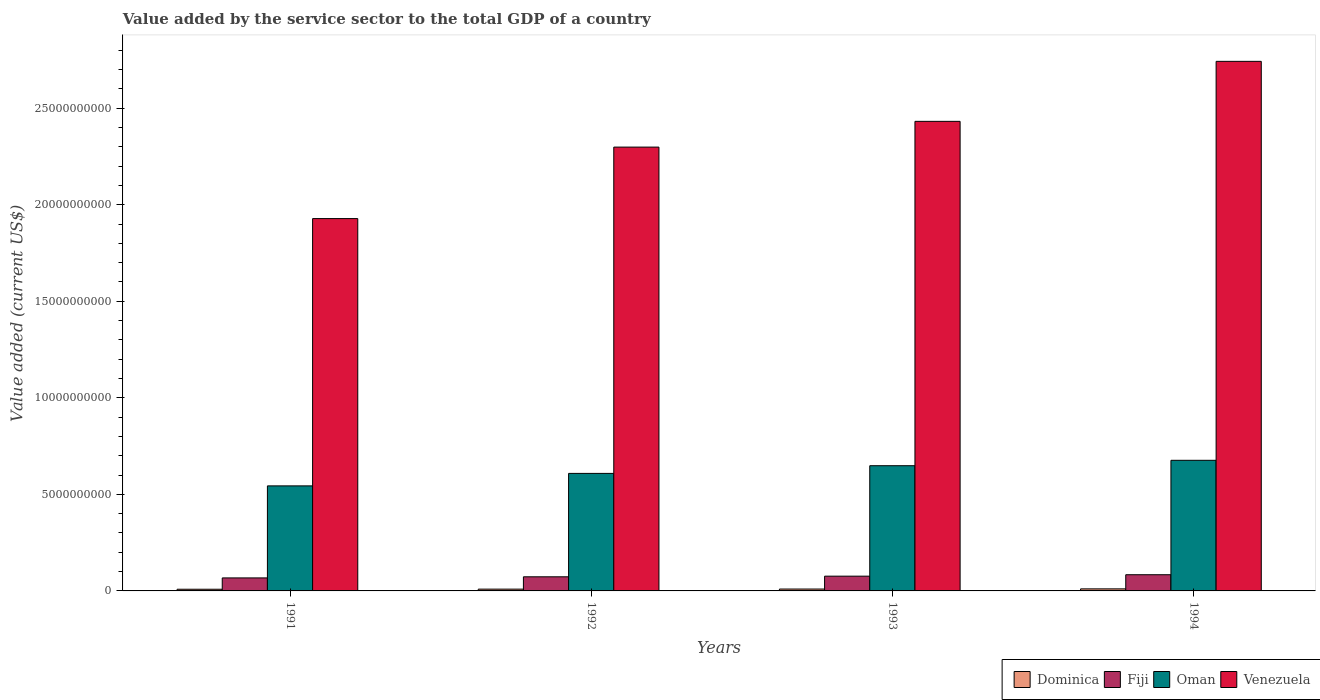How many groups of bars are there?
Your answer should be very brief. 4. In how many cases, is the number of bars for a given year not equal to the number of legend labels?
Ensure brevity in your answer.  0. What is the value added by the service sector to the total GDP in Oman in 1993?
Keep it short and to the point. 6.48e+09. Across all years, what is the maximum value added by the service sector to the total GDP in Oman?
Keep it short and to the point. 6.76e+09. Across all years, what is the minimum value added by the service sector to the total GDP in Dominica?
Keep it short and to the point. 8.67e+07. In which year was the value added by the service sector to the total GDP in Venezuela maximum?
Your answer should be compact. 1994. What is the total value added by the service sector to the total GDP in Venezuela in the graph?
Offer a terse response. 9.40e+1. What is the difference between the value added by the service sector to the total GDP in Fiji in 1991 and that in 1994?
Your answer should be very brief. -1.64e+08. What is the difference between the value added by the service sector to the total GDP in Dominica in 1992 and the value added by the service sector to the total GDP in Venezuela in 1993?
Keep it short and to the point. -2.42e+1. What is the average value added by the service sector to the total GDP in Oman per year?
Your answer should be compact. 6.19e+09. In the year 1993, what is the difference between the value added by the service sector to the total GDP in Fiji and value added by the service sector to the total GDP in Oman?
Provide a short and direct response. -5.72e+09. In how many years, is the value added by the service sector to the total GDP in Fiji greater than 18000000000 US$?
Offer a very short reply. 0. What is the ratio of the value added by the service sector to the total GDP in Fiji in 1991 to that in 1994?
Your answer should be very brief. 0.8. Is the value added by the service sector to the total GDP in Venezuela in 1991 less than that in 1993?
Make the answer very short. Yes. Is the difference between the value added by the service sector to the total GDP in Fiji in 1992 and 1994 greater than the difference between the value added by the service sector to the total GDP in Oman in 1992 and 1994?
Provide a short and direct response. Yes. What is the difference between the highest and the second highest value added by the service sector to the total GDP in Oman?
Your answer should be compact. 2.81e+08. What is the difference between the highest and the lowest value added by the service sector to the total GDP in Oman?
Give a very brief answer. 1.32e+09. Is the sum of the value added by the service sector to the total GDP in Venezuela in 1991 and 1994 greater than the maximum value added by the service sector to the total GDP in Fiji across all years?
Your answer should be very brief. Yes. What does the 1st bar from the left in 1991 represents?
Provide a short and direct response. Dominica. What does the 4th bar from the right in 1993 represents?
Ensure brevity in your answer.  Dominica. Is it the case that in every year, the sum of the value added by the service sector to the total GDP in Venezuela and value added by the service sector to the total GDP in Oman is greater than the value added by the service sector to the total GDP in Fiji?
Your answer should be compact. Yes. How many bars are there?
Your answer should be very brief. 16. How many years are there in the graph?
Keep it short and to the point. 4. What is the difference between two consecutive major ticks on the Y-axis?
Make the answer very short. 5.00e+09. Does the graph contain grids?
Keep it short and to the point. No. Where does the legend appear in the graph?
Your response must be concise. Bottom right. What is the title of the graph?
Keep it short and to the point. Value added by the service sector to the total GDP of a country. What is the label or title of the Y-axis?
Your response must be concise. Value added (current US$). What is the Value added (current US$) of Dominica in 1991?
Your answer should be compact. 8.67e+07. What is the Value added (current US$) in Fiji in 1991?
Your answer should be compact. 6.74e+08. What is the Value added (current US$) of Oman in 1991?
Your response must be concise. 5.44e+09. What is the Value added (current US$) of Venezuela in 1991?
Your response must be concise. 1.93e+1. What is the Value added (current US$) in Dominica in 1992?
Your answer should be very brief. 9.25e+07. What is the Value added (current US$) of Fiji in 1992?
Your response must be concise. 7.31e+08. What is the Value added (current US$) in Oman in 1992?
Your answer should be very brief. 6.09e+09. What is the Value added (current US$) in Venezuela in 1992?
Your answer should be compact. 2.30e+1. What is the Value added (current US$) in Dominica in 1993?
Give a very brief answer. 9.78e+07. What is the Value added (current US$) of Fiji in 1993?
Give a very brief answer. 7.64e+08. What is the Value added (current US$) in Oman in 1993?
Provide a short and direct response. 6.48e+09. What is the Value added (current US$) in Venezuela in 1993?
Make the answer very short. 2.43e+1. What is the Value added (current US$) in Dominica in 1994?
Your answer should be very brief. 1.06e+08. What is the Value added (current US$) of Fiji in 1994?
Your response must be concise. 8.38e+08. What is the Value added (current US$) in Oman in 1994?
Your response must be concise. 6.76e+09. What is the Value added (current US$) of Venezuela in 1994?
Give a very brief answer. 2.74e+1. Across all years, what is the maximum Value added (current US$) in Dominica?
Give a very brief answer. 1.06e+08. Across all years, what is the maximum Value added (current US$) in Fiji?
Offer a very short reply. 8.38e+08. Across all years, what is the maximum Value added (current US$) in Oman?
Your response must be concise. 6.76e+09. Across all years, what is the maximum Value added (current US$) in Venezuela?
Ensure brevity in your answer.  2.74e+1. Across all years, what is the minimum Value added (current US$) of Dominica?
Provide a succinct answer. 8.67e+07. Across all years, what is the minimum Value added (current US$) of Fiji?
Offer a terse response. 6.74e+08. Across all years, what is the minimum Value added (current US$) in Oman?
Provide a short and direct response. 5.44e+09. Across all years, what is the minimum Value added (current US$) of Venezuela?
Provide a short and direct response. 1.93e+1. What is the total Value added (current US$) of Dominica in the graph?
Your response must be concise. 3.83e+08. What is the total Value added (current US$) of Fiji in the graph?
Provide a succinct answer. 3.01e+09. What is the total Value added (current US$) of Oman in the graph?
Your response must be concise. 2.48e+1. What is the total Value added (current US$) of Venezuela in the graph?
Offer a terse response. 9.40e+1. What is the difference between the Value added (current US$) in Dominica in 1991 and that in 1992?
Your response must be concise. -5.76e+06. What is the difference between the Value added (current US$) in Fiji in 1991 and that in 1992?
Provide a succinct answer. -5.74e+07. What is the difference between the Value added (current US$) of Oman in 1991 and that in 1992?
Your response must be concise. -6.47e+08. What is the difference between the Value added (current US$) of Venezuela in 1991 and that in 1992?
Give a very brief answer. -3.70e+09. What is the difference between the Value added (current US$) in Dominica in 1991 and that in 1993?
Offer a very short reply. -1.11e+07. What is the difference between the Value added (current US$) in Fiji in 1991 and that in 1993?
Your response must be concise. -9.05e+07. What is the difference between the Value added (current US$) of Oman in 1991 and that in 1993?
Offer a very short reply. -1.04e+09. What is the difference between the Value added (current US$) in Venezuela in 1991 and that in 1993?
Provide a short and direct response. -5.04e+09. What is the difference between the Value added (current US$) in Dominica in 1991 and that in 1994?
Provide a short and direct response. -1.94e+07. What is the difference between the Value added (current US$) of Fiji in 1991 and that in 1994?
Make the answer very short. -1.64e+08. What is the difference between the Value added (current US$) of Oman in 1991 and that in 1994?
Provide a short and direct response. -1.32e+09. What is the difference between the Value added (current US$) of Venezuela in 1991 and that in 1994?
Provide a short and direct response. -8.14e+09. What is the difference between the Value added (current US$) of Dominica in 1992 and that in 1993?
Keep it short and to the point. -5.36e+06. What is the difference between the Value added (current US$) of Fiji in 1992 and that in 1993?
Your response must be concise. -3.31e+07. What is the difference between the Value added (current US$) of Oman in 1992 and that in 1993?
Your answer should be compact. -3.97e+08. What is the difference between the Value added (current US$) in Venezuela in 1992 and that in 1993?
Provide a succinct answer. -1.33e+09. What is the difference between the Value added (current US$) of Dominica in 1992 and that in 1994?
Your answer should be compact. -1.36e+07. What is the difference between the Value added (current US$) of Fiji in 1992 and that in 1994?
Your answer should be very brief. -1.07e+08. What is the difference between the Value added (current US$) in Oman in 1992 and that in 1994?
Ensure brevity in your answer.  -6.78e+08. What is the difference between the Value added (current US$) of Venezuela in 1992 and that in 1994?
Keep it short and to the point. -4.44e+09. What is the difference between the Value added (current US$) of Dominica in 1993 and that in 1994?
Provide a short and direct response. -8.29e+06. What is the difference between the Value added (current US$) of Fiji in 1993 and that in 1994?
Offer a very short reply. -7.38e+07. What is the difference between the Value added (current US$) of Oman in 1993 and that in 1994?
Keep it short and to the point. -2.81e+08. What is the difference between the Value added (current US$) of Venezuela in 1993 and that in 1994?
Provide a short and direct response. -3.11e+09. What is the difference between the Value added (current US$) in Dominica in 1991 and the Value added (current US$) in Fiji in 1992?
Provide a succinct answer. -6.45e+08. What is the difference between the Value added (current US$) in Dominica in 1991 and the Value added (current US$) in Oman in 1992?
Provide a succinct answer. -6.00e+09. What is the difference between the Value added (current US$) of Dominica in 1991 and the Value added (current US$) of Venezuela in 1992?
Your answer should be compact. -2.29e+1. What is the difference between the Value added (current US$) in Fiji in 1991 and the Value added (current US$) in Oman in 1992?
Provide a short and direct response. -5.41e+09. What is the difference between the Value added (current US$) in Fiji in 1991 and the Value added (current US$) in Venezuela in 1992?
Your answer should be very brief. -2.23e+1. What is the difference between the Value added (current US$) in Oman in 1991 and the Value added (current US$) in Venezuela in 1992?
Keep it short and to the point. -1.75e+1. What is the difference between the Value added (current US$) in Dominica in 1991 and the Value added (current US$) in Fiji in 1993?
Offer a terse response. -6.78e+08. What is the difference between the Value added (current US$) in Dominica in 1991 and the Value added (current US$) in Oman in 1993?
Your answer should be very brief. -6.40e+09. What is the difference between the Value added (current US$) of Dominica in 1991 and the Value added (current US$) of Venezuela in 1993?
Make the answer very short. -2.42e+1. What is the difference between the Value added (current US$) in Fiji in 1991 and the Value added (current US$) in Oman in 1993?
Your response must be concise. -5.81e+09. What is the difference between the Value added (current US$) of Fiji in 1991 and the Value added (current US$) of Venezuela in 1993?
Offer a terse response. -2.36e+1. What is the difference between the Value added (current US$) in Oman in 1991 and the Value added (current US$) in Venezuela in 1993?
Your response must be concise. -1.89e+1. What is the difference between the Value added (current US$) in Dominica in 1991 and the Value added (current US$) in Fiji in 1994?
Give a very brief answer. -7.52e+08. What is the difference between the Value added (current US$) of Dominica in 1991 and the Value added (current US$) of Oman in 1994?
Offer a terse response. -6.68e+09. What is the difference between the Value added (current US$) of Dominica in 1991 and the Value added (current US$) of Venezuela in 1994?
Ensure brevity in your answer.  -2.73e+1. What is the difference between the Value added (current US$) in Fiji in 1991 and the Value added (current US$) in Oman in 1994?
Provide a succinct answer. -6.09e+09. What is the difference between the Value added (current US$) of Fiji in 1991 and the Value added (current US$) of Venezuela in 1994?
Your answer should be compact. -2.67e+1. What is the difference between the Value added (current US$) of Oman in 1991 and the Value added (current US$) of Venezuela in 1994?
Keep it short and to the point. -2.20e+1. What is the difference between the Value added (current US$) of Dominica in 1992 and the Value added (current US$) of Fiji in 1993?
Keep it short and to the point. -6.72e+08. What is the difference between the Value added (current US$) in Dominica in 1992 and the Value added (current US$) in Oman in 1993?
Offer a terse response. -6.39e+09. What is the difference between the Value added (current US$) in Dominica in 1992 and the Value added (current US$) in Venezuela in 1993?
Your response must be concise. -2.42e+1. What is the difference between the Value added (current US$) of Fiji in 1992 and the Value added (current US$) of Oman in 1993?
Provide a succinct answer. -5.75e+09. What is the difference between the Value added (current US$) of Fiji in 1992 and the Value added (current US$) of Venezuela in 1993?
Provide a short and direct response. -2.36e+1. What is the difference between the Value added (current US$) in Oman in 1992 and the Value added (current US$) in Venezuela in 1993?
Your response must be concise. -1.82e+1. What is the difference between the Value added (current US$) of Dominica in 1992 and the Value added (current US$) of Fiji in 1994?
Your answer should be compact. -7.46e+08. What is the difference between the Value added (current US$) of Dominica in 1992 and the Value added (current US$) of Oman in 1994?
Provide a succinct answer. -6.67e+09. What is the difference between the Value added (current US$) of Dominica in 1992 and the Value added (current US$) of Venezuela in 1994?
Offer a very short reply. -2.73e+1. What is the difference between the Value added (current US$) in Fiji in 1992 and the Value added (current US$) in Oman in 1994?
Offer a very short reply. -6.03e+09. What is the difference between the Value added (current US$) in Fiji in 1992 and the Value added (current US$) in Venezuela in 1994?
Your response must be concise. -2.67e+1. What is the difference between the Value added (current US$) of Oman in 1992 and the Value added (current US$) of Venezuela in 1994?
Offer a very short reply. -2.13e+1. What is the difference between the Value added (current US$) of Dominica in 1993 and the Value added (current US$) of Fiji in 1994?
Provide a succinct answer. -7.40e+08. What is the difference between the Value added (current US$) of Dominica in 1993 and the Value added (current US$) of Oman in 1994?
Provide a succinct answer. -6.67e+09. What is the difference between the Value added (current US$) in Dominica in 1993 and the Value added (current US$) in Venezuela in 1994?
Provide a short and direct response. -2.73e+1. What is the difference between the Value added (current US$) in Fiji in 1993 and the Value added (current US$) in Oman in 1994?
Your answer should be very brief. -6.00e+09. What is the difference between the Value added (current US$) in Fiji in 1993 and the Value added (current US$) in Venezuela in 1994?
Offer a terse response. -2.67e+1. What is the difference between the Value added (current US$) of Oman in 1993 and the Value added (current US$) of Venezuela in 1994?
Your answer should be very brief. -2.09e+1. What is the average Value added (current US$) in Dominica per year?
Keep it short and to the point. 9.58e+07. What is the average Value added (current US$) of Fiji per year?
Provide a succinct answer. 7.52e+08. What is the average Value added (current US$) of Oman per year?
Ensure brevity in your answer.  6.19e+09. What is the average Value added (current US$) of Venezuela per year?
Make the answer very short. 2.35e+1. In the year 1991, what is the difference between the Value added (current US$) in Dominica and Value added (current US$) in Fiji?
Your answer should be compact. -5.87e+08. In the year 1991, what is the difference between the Value added (current US$) of Dominica and Value added (current US$) of Oman?
Provide a succinct answer. -5.35e+09. In the year 1991, what is the difference between the Value added (current US$) in Dominica and Value added (current US$) in Venezuela?
Your answer should be very brief. -1.92e+1. In the year 1991, what is the difference between the Value added (current US$) in Fiji and Value added (current US$) in Oman?
Ensure brevity in your answer.  -4.77e+09. In the year 1991, what is the difference between the Value added (current US$) in Fiji and Value added (current US$) in Venezuela?
Ensure brevity in your answer.  -1.86e+1. In the year 1991, what is the difference between the Value added (current US$) of Oman and Value added (current US$) of Venezuela?
Give a very brief answer. -1.38e+1. In the year 1992, what is the difference between the Value added (current US$) of Dominica and Value added (current US$) of Fiji?
Offer a very short reply. -6.39e+08. In the year 1992, what is the difference between the Value added (current US$) in Dominica and Value added (current US$) in Oman?
Your answer should be very brief. -5.99e+09. In the year 1992, what is the difference between the Value added (current US$) of Dominica and Value added (current US$) of Venezuela?
Offer a terse response. -2.29e+1. In the year 1992, what is the difference between the Value added (current US$) in Fiji and Value added (current US$) in Oman?
Give a very brief answer. -5.35e+09. In the year 1992, what is the difference between the Value added (current US$) of Fiji and Value added (current US$) of Venezuela?
Ensure brevity in your answer.  -2.23e+1. In the year 1992, what is the difference between the Value added (current US$) of Oman and Value added (current US$) of Venezuela?
Offer a very short reply. -1.69e+1. In the year 1993, what is the difference between the Value added (current US$) of Dominica and Value added (current US$) of Fiji?
Offer a very short reply. -6.67e+08. In the year 1993, what is the difference between the Value added (current US$) of Dominica and Value added (current US$) of Oman?
Offer a very short reply. -6.39e+09. In the year 1993, what is the difference between the Value added (current US$) in Dominica and Value added (current US$) in Venezuela?
Your answer should be compact. -2.42e+1. In the year 1993, what is the difference between the Value added (current US$) in Fiji and Value added (current US$) in Oman?
Your answer should be compact. -5.72e+09. In the year 1993, what is the difference between the Value added (current US$) of Fiji and Value added (current US$) of Venezuela?
Provide a succinct answer. -2.36e+1. In the year 1993, what is the difference between the Value added (current US$) in Oman and Value added (current US$) in Venezuela?
Give a very brief answer. -1.78e+1. In the year 1994, what is the difference between the Value added (current US$) in Dominica and Value added (current US$) in Fiji?
Offer a terse response. -7.32e+08. In the year 1994, what is the difference between the Value added (current US$) in Dominica and Value added (current US$) in Oman?
Offer a terse response. -6.66e+09. In the year 1994, what is the difference between the Value added (current US$) in Dominica and Value added (current US$) in Venezuela?
Keep it short and to the point. -2.73e+1. In the year 1994, what is the difference between the Value added (current US$) in Fiji and Value added (current US$) in Oman?
Give a very brief answer. -5.93e+09. In the year 1994, what is the difference between the Value added (current US$) of Fiji and Value added (current US$) of Venezuela?
Your answer should be compact. -2.66e+1. In the year 1994, what is the difference between the Value added (current US$) in Oman and Value added (current US$) in Venezuela?
Offer a very short reply. -2.07e+1. What is the ratio of the Value added (current US$) in Dominica in 1991 to that in 1992?
Offer a terse response. 0.94. What is the ratio of the Value added (current US$) in Fiji in 1991 to that in 1992?
Provide a succinct answer. 0.92. What is the ratio of the Value added (current US$) of Oman in 1991 to that in 1992?
Offer a terse response. 0.89. What is the ratio of the Value added (current US$) in Venezuela in 1991 to that in 1992?
Your answer should be compact. 0.84. What is the ratio of the Value added (current US$) of Dominica in 1991 to that in 1993?
Keep it short and to the point. 0.89. What is the ratio of the Value added (current US$) of Fiji in 1991 to that in 1993?
Provide a short and direct response. 0.88. What is the ratio of the Value added (current US$) in Oman in 1991 to that in 1993?
Make the answer very short. 0.84. What is the ratio of the Value added (current US$) in Venezuela in 1991 to that in 1993?
Ensure brevity in your answer.  0.79. What is the ratio of the Value added (current US$) of Dominica in 1991 to that in 1994?
Ensure brevity in your answer.  0.82. What is the ratio of the Value added (current US$) in Fiji in 1991 to that in 1994?
Keep it short and to the point. 0.8. What is the ratio of the Value added (current US$) of Oman in 1991 to that in 1994?
Make the answer very short. 0.8. What is the ratio of the Value added (current US$) in Venezuela in 1991 to that in 1994?
Keep it short and to the point. 0.7. What is the ratio of the Value added (current US$) in Dominica in 1992 to that in 1993?
Keep it short and to the point. 0.95. What is the ratio of the Value added (current US$) in Fiji in 1992 to that in 1993?
Offer a terse response. 0.96. What is the ratio of the Value added (current US$) in Oman in 1992 to that in 1993?
Keep it short and to the point. 0.94. What is the ratio of the Value added (current US$) of Venezuela in 1992 to that in 1993?
Give a very brief answer. 0.95. What is the ratio of the Value added (current US$) of Dominica in 1992 to that in 1994?
Provide a succinct answer. 0.87. What is the ratio of the Value added (current US$) of Fiji in 1992 to that in 1994?
Give a very brief answer. 0.87. What is the ratio of the Value added (current US$) in Oman in 1992 to that in 1994?
Give a very brief answer. 0.9. What is the ratio of the Value added (current US$) of Venezuela in 1992 to that in 1994?
Provide a short and direct response. 0.84. What is the ratio of the Value added (current US$) of Dominica in 1993 to that in 1994?
Your response must be concise. 0.92. What is the ratio of the Value added (current US$) of Fiji in 1993 to that in 1994?
Keep it short and to the point. 0.91. What is the ratio of the Value added (current US$) of Oman in 1993 to that in 1994?
Offer a very short reply. 0.96. What is the ratio of the Value added (current US$) in Venezuela in 1993 to that in 1994?
Your response must be concise. 0.89. What is the difference between the highest and the second highest Value added (current US$) of Dominica?
Ensure brevity in your answer.  8.29e+06. What is the difference between the highest and the second highest Value added (current US$) of Fiji?
Offer a terse response. 7.38e+07. What is the difference between the highest and the second highest Value added (current US$) in Oman?
Make the answer very short. 2.81e+08. What is the difference between the highest and the second highest Value added (current US$) in Venezuela?
Provide a succinct answer. 3.11e+09. What is the difference between the highest and the lowest Value added (current US$) in Dominica?
Offer a terse response. 1.94e+07. What is the difference between the highest and the lowest Value added (current US$) of Fiji?
Your answer should be compact. 1.64e+08. What is the difference between the highest and the lowest Value added (current US$) in Oman?
Ensure brevity in your answer.  1.32e+09. What is the difference between the highest and the lowest Value added (current US$) of Venezuela?
Your answer should be very brief. 8.14e+09. 